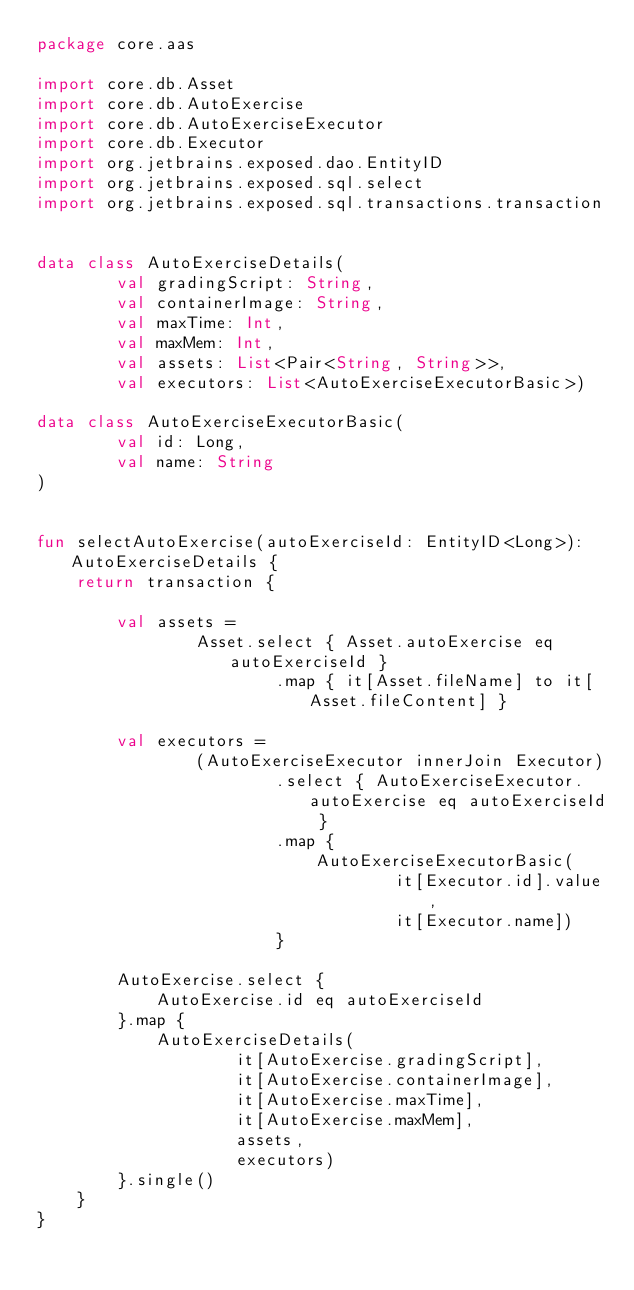<code> <loc_0><loc_0><loc_500><loc_500><_Kotlin_>package core.aas

import core.db.Asset
import core.db.AutoExercise
import core.db.AutoExerciseExecutor
import core.db.Executor
import org.jetbrains.exposed.dao.EntityID
import org.jetbrains.exposed.sql.select
import org.jetbrains.exposed.sql.transactions.transaction


data class AutoExerciseDetails(
        val gradingScript: String,
        val containerImage: String,
        val maxTime: Int,
        val maxMem: Int,
        val assets: List<Pair<String, String>>,
        val executors: List<AutoExerciseExecutorBasic>)

data class AutoExerciseExecutorBasic(
        val id: Long,
        val name: String
)


fun selectAutoExercise(autoExerciseId: EntityID<Long>): AutoExerciseDetails {
    return transaction {

        val assets =
                Asset.select { Asset.autoExercise eq autoExerciseId }
                        .map { it[Asset.fileName] to it[Asset.fileContent] }

        val executors =
                (AutoExerciseExecutor innerJoin Executor)
                        .select { AutoExerciseExecutor.autoExercise eq autoExerciseId }
                        .map {
                            AutoExerciseExecutorBasic(
                                    it[Executor.id].value,
                                    it[Executor.name])
                        }

        AutoExercise.select {
            AutoExercise.id eq autoExerciseId
        }.map {
            AutoExerciseDetails(
                    it[AutoExercise.gradingScript],
                    it[AutoExercise.containerImage],
                    it[AutoExercise.maxTime],
                    it[AutoExercise.maxMem],
                    assets,
                    executors)
        }.single()
    }
}</code> 